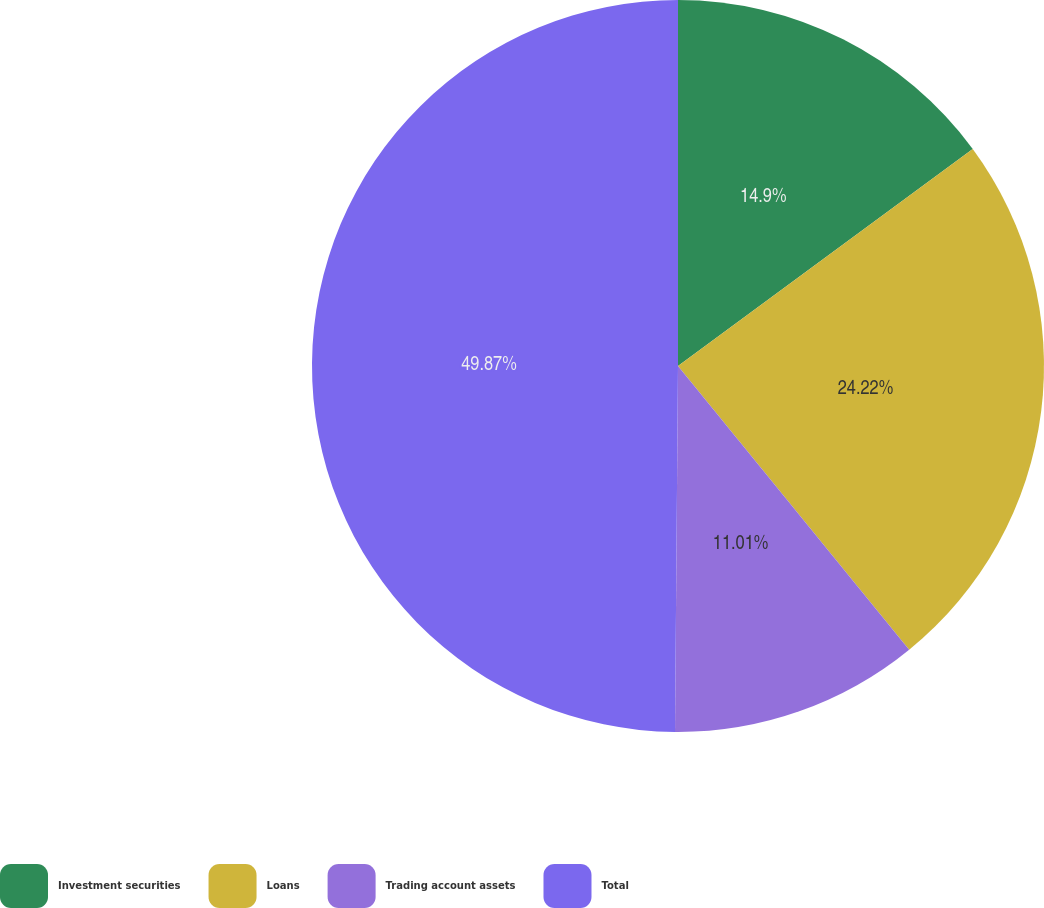Convert chart to OTSL. <chart><loc_0><loc_0><loc_500><loc_500><pie_chart><fcel>Investment securities<fcel>Loans<fcel>Trading account assets<fcel>Total<nl><fcel>14.9%<fcel>24.22%<fcel>11.01%<fcel>49.87%<nl></chart> 